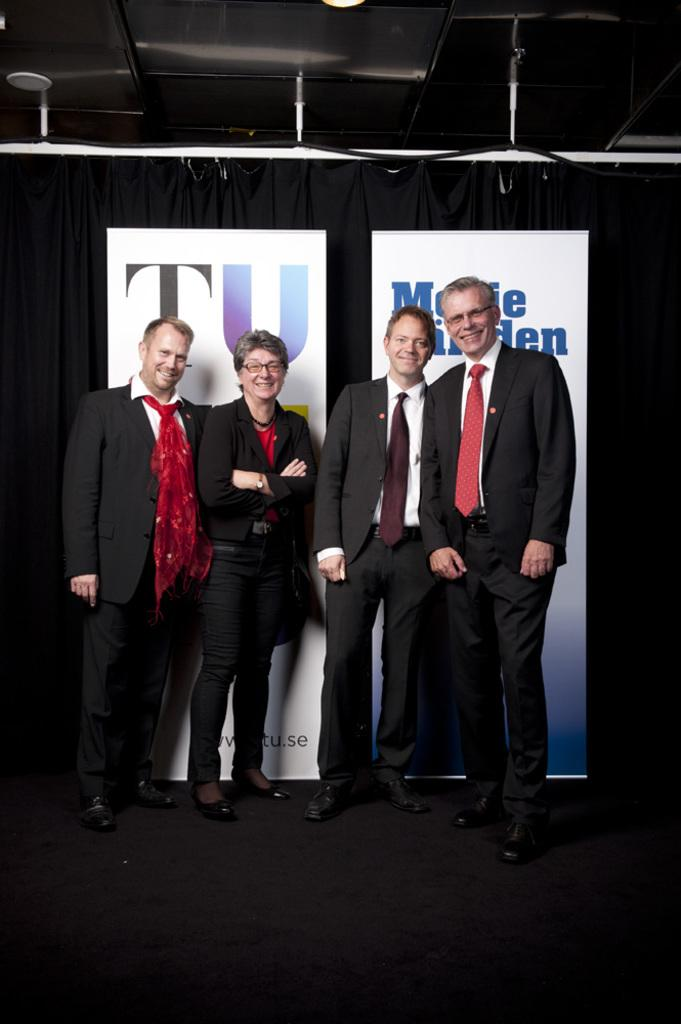How many people are in the image? There are four persons in the image. What are the persons doing in the image? The persons are standing in the image. What expressions do the persons have in the image? The persons are smiling in the image. What can be seen in the background of the image? There is a curtain and banners in the background of the image. Can you see the mom of one of the persons in the image? There is no indication in the image that any of the persons have a mom present. Is there a snake visible in the image? There is no snake present in the image. 